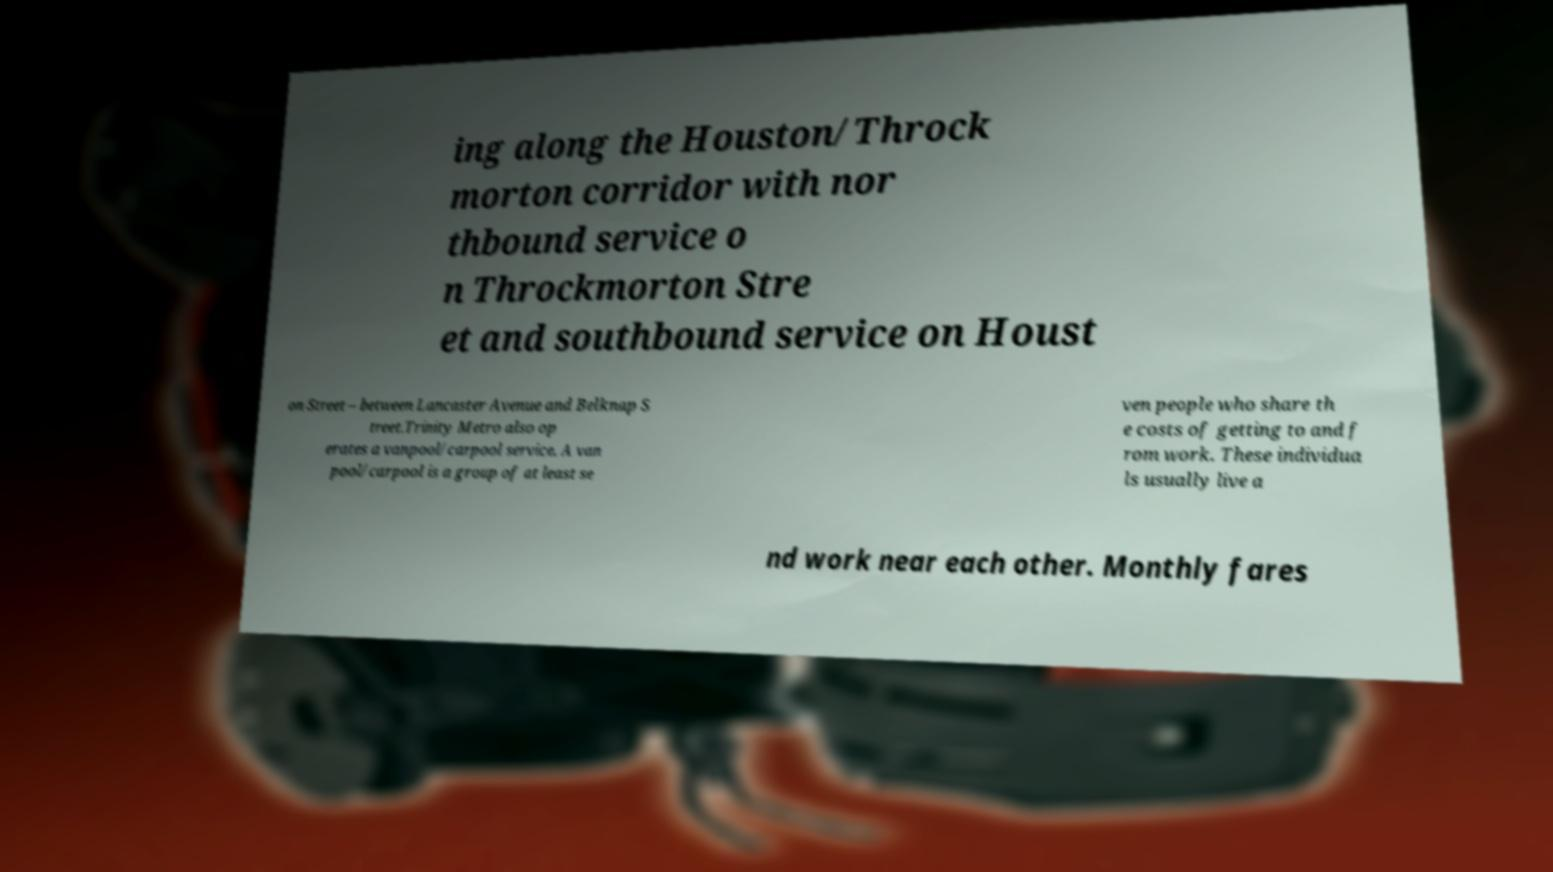Can you accurately transcribe the text from the provided image for me? ing along the Houston/Throck morton corridor with nor thbound service o n Throckmorton Stre et and southbound service on Houst on Street – between Lancaster Avenue and Belknap S treet.Trinity Metro also op erates a vanpool/carpool service. A van pool/carpool is a group of at least se ven people who share th e costs of getting to and f rom work. These individua ls usually live a nd work near each other. Monthly fares 